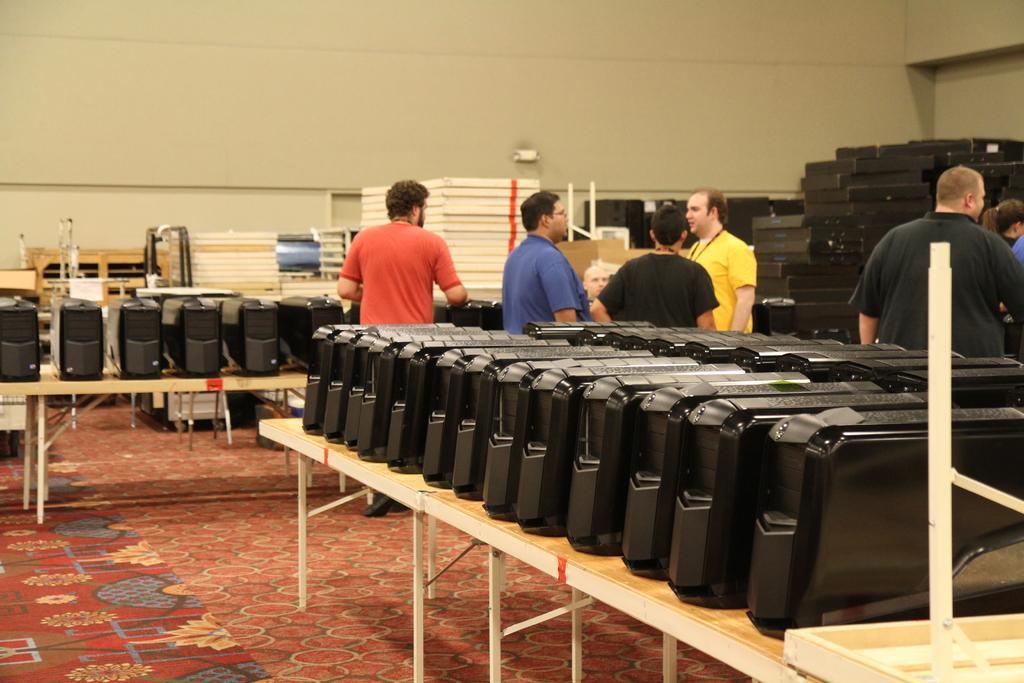Can you describe this image briefly? there are cpus present on the table. behind that people are standing and talking to each other. 